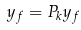Convert formula to latex. <formula><loc_0><loc_0><loc_500><loc_500>y _ { f } = P _ { k } y _ { f }</formula> 